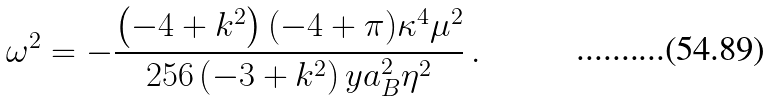<formula> <loc_0><loc_0><loc_500><loc_500>\omega ^ { 2 } = - \frac { \left ( - 4 + k ^ { 2 } \right ) ( - 4 + \pi ) \kappa ^ { 4 } \mu ^ { 2 } } { 2 5 6 \left ( - 3 + k ^ { 2 } \right ) y a _ { B } ^ { 2 } \eta ^ { 2 } } \, .</formula> 